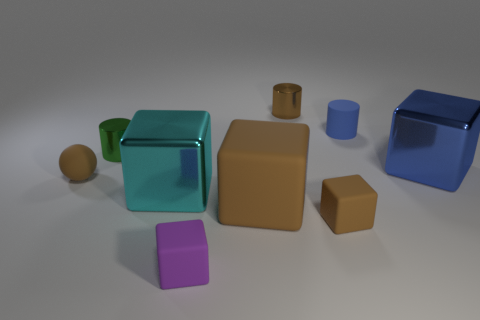Subtract all purple rubber cubes. How many cubes are left? 4 Subtract all green blocks. Subtract all cyan spheres. How many blocks are left? 5 Subtract all cubes. How many objects are left? 4 Add 5 big cyan shiny things. How many big cyan shiny things are left? 6 Add 8 large red things. How many large red things exist? 8 Subtract 0 red cylinders. How many objects are left? 9 Subtract all large cubes. Subtract all big rubber things. How many objects are left? 5 